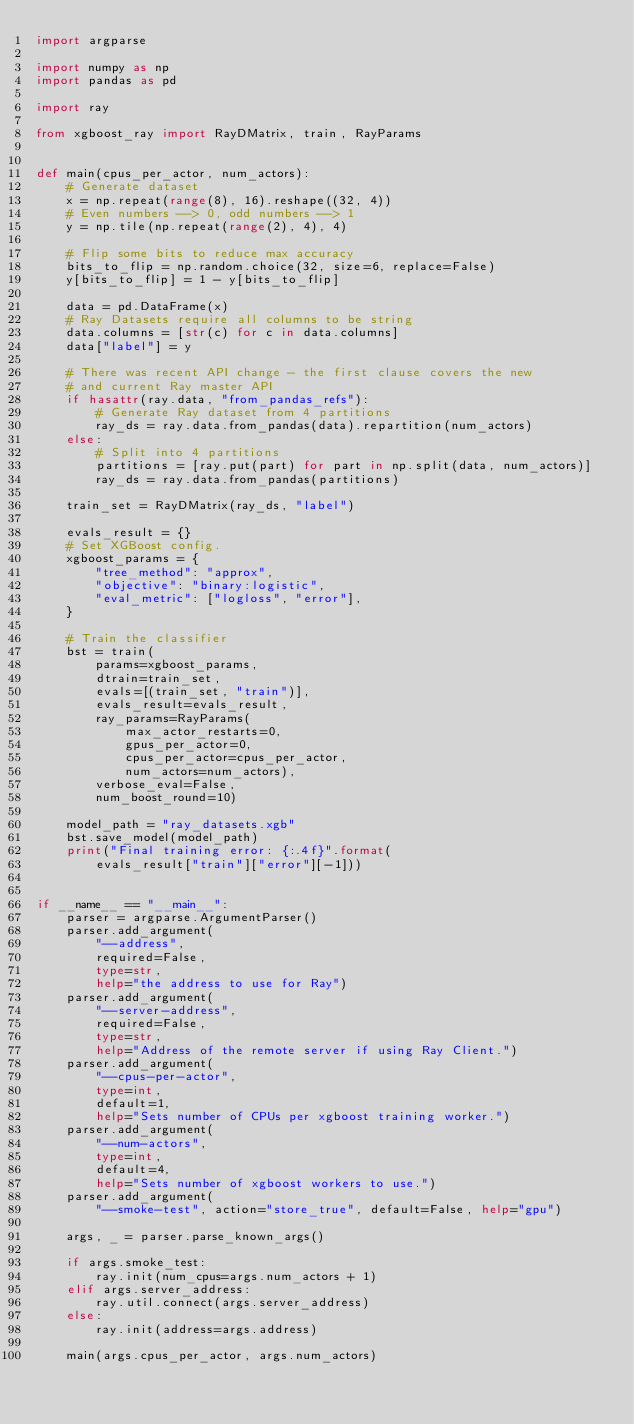Convert code to text. <code><loc_0><loc_0><loc_500><loc_500><_Python_>import argparse

import numpy as np
import pandas as pd

import ray

from xgboost_ray import RayDMatrix, train, RayParams


def main(cpus_per_actor, num_actors):
    # Generate dataset
    x = np.repeat(range(8), 16).reshape((32, 4))
    # Even numbers --> 0, odd numbers --> 1
    y = np.tile(np.repeat(range(2), 4), 4)

    # Flip some bits to reduce max accuracy
    bits_to_flip = np.random.choice(32, size=6, replace=False)
    y[bits_to_flip] = 1 - y[bits_to_flip]

    data = pd.DataFrame(x)
    # Ray Datasets require all columns to be string
    data.columns = [str(c) for c in data.columns]
    data["label"] = y

    # There was recent API change - the first clause covers the new
    # and current Ray master API
    if hasattr(ray.data, "from_pandas_refs"):
        # Generate Ray dataset from 4 partitions
        ray_ds = ray.data.from_pandas(data).repartition(num_actors)
    else:
        # Split into 4 partitions
        partitions = [ray.put(part) for part in np.split(data, num_actors)]
        ray_ds = ray.data.from_pandas(partitions)

    train_set = RayDMatrix(ray_ds, "label")

    evals_result = {}
    # Set XGBoost config.
    xgboost_params = {
        "tree_method": "approx",
        "objective": "binary:logistic",
        "eval_metric": ["logloss", "error"],
    }

    # Train the classifier
    bst = train(
        params=xgboost_params,
        dtrain=train_set,
        evals=[(train_set, "train")],
        evals_result=evals_result,
        ray_params=RayParams(
            max_actor_restarts=0,
            gpus_per_actor=0,
            cpus_per_actor=cpus_per_actor,
            num_actors=num_actors),
        verbose_eval=False,
        num_boost_round=10)

    model_path = "ray_datasets.xgb"
    bst.save_model(model_path)
    print("Final training error: {:.4f}".format(
        evals_result["train"]["error"][-1]))


if __name__ == "__main__":
    parser = argparse.ArgumentParser()
    parser.add_argument(
        "--address",
        required=False,
        type=str,
        help="the address to use for Ray")
    parser.add_argument(
        "--server-address",
        required=False,
        type=str,
        help="Address of the remote server if using Ray Client.")
    parser.add_argument(
        "--cpus-per-actor",
        type=int,
        default=1,
        help="Sets number of CPUs per xgboost training worker.")
    parser.add_argument(
        "--num-actors",
        type=int,
        default=4,
        help="Sets number of xgboost workers to use.")
    parser.add_argument(
        "--smoke-test", action="store_true", default=False, help="gpu")

    args, _ = parser.parse_known_args()

    if args.smoke_test:
        ray.init(num_cpus=args.num_actors + 1)
    elif args.server_address:
        ray.util.connect(args.server_address)
    else:
        ray.init(address=args.address)

    main(args.cpus_per_actor, args.num_actors)
</code> 